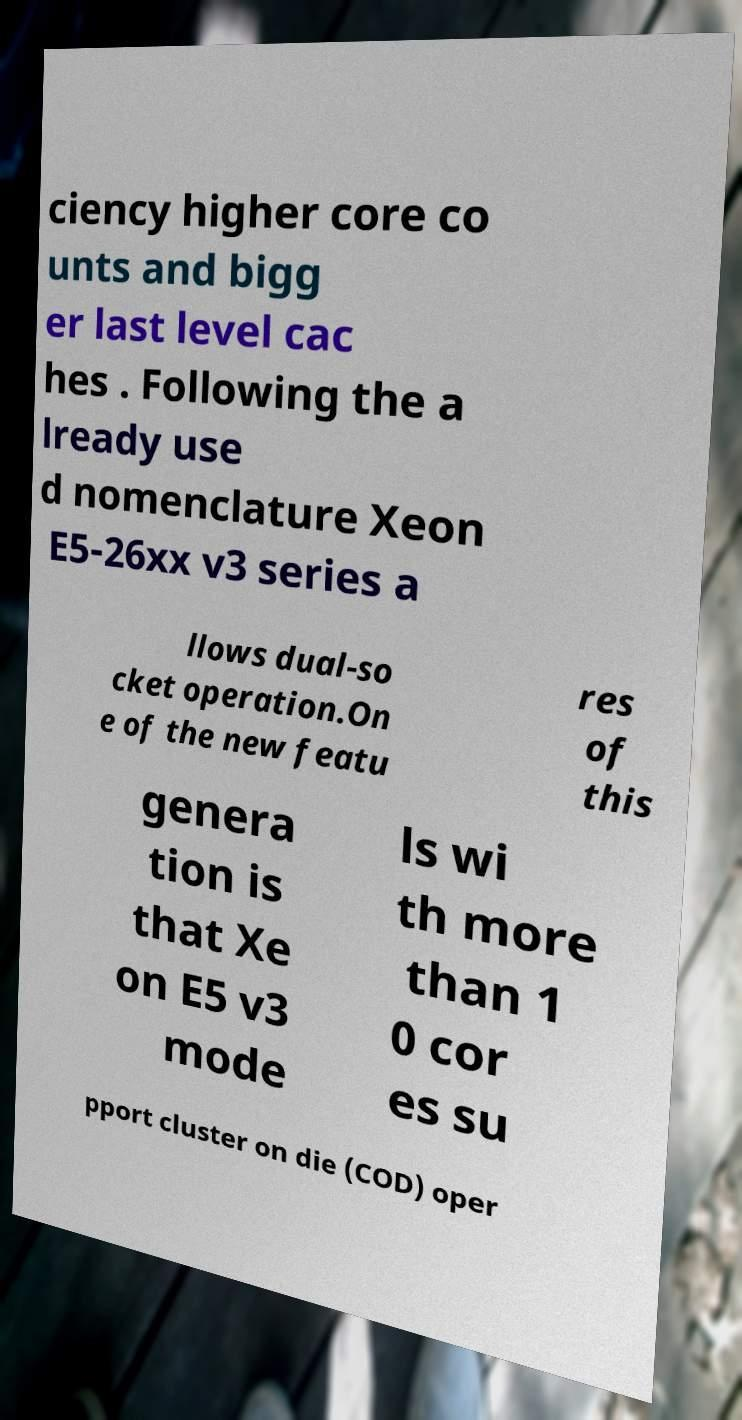Could you extract and type out the text from this image? ciency higher core co unts and bigg er last level cac hes . Following the a lready use d nomenclature Xeon E5-26xx v3 series a llows dual-so cket operation.On e of the new featu res of this genera tion is that Xe on E5 v3 mode ls wi th more than 1 0 cor es su pport cluster on die (COD) oper 